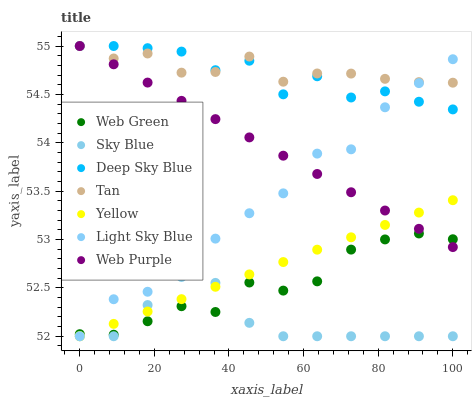Does Sky Blue have the minimum area under the curve?
Answer yes or no. Yes. Does Tan have the maximum area under the curve?
Answer yes or no. Yes. Does Web Purple have the minimum area under the curve?
Answer yes or no. No. Does Web Purple have the maximum area under the curve?
Answer yes or no. No. Is Yellow the smoothest?
Answer yes or no. Yes. Is Deep Sky Blue the roughest?
Answer yes or no. Yes. Is Web Purple the smoothest?
Answer yes or no. No. Is Web Purple the roughest?
Answer yes or no. No. Does Yellow have the lowest value?
Answer yes or no. Yes. Does Web Purple have the lowest value?
Answer yes or no. No. Does Tan have the highest value?
Answer yes or no. Yes. Does Light Sky Blue have the highest value?
Answer yes or no. No. Is Yellow less than Deep Sky Blue?
Answer yes or no. Yes. Is Tan greater than Sky Blue?
Answer yes or no. Yes. Does Yellow intersect Web Purple?
Answer yes or no. Yes. Is Yellow less than Web Purple?
Answer yes or no. No. Is Yellow greater than Web Purple?
Answer yes or no. No. Does Yellow intersect Deep Sky Blue?
Answer yes or no. No. 